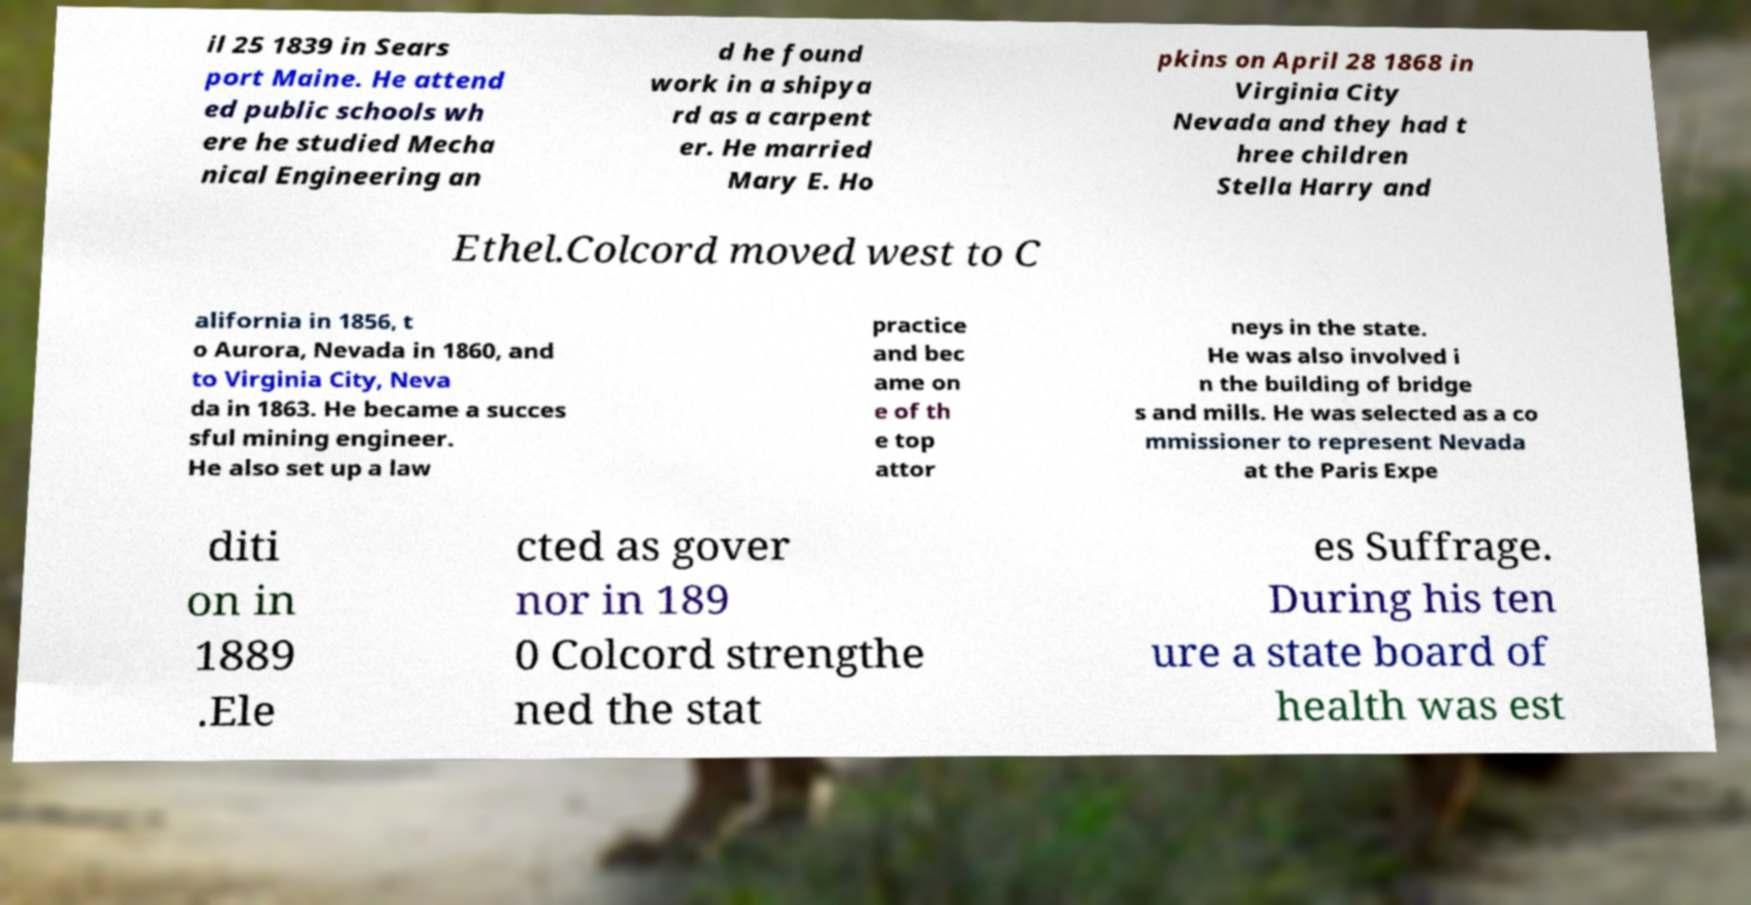Please read and relay the text visible in this image. What does it say? il 25 1839 in Sears port Maine. He attend ed public schools wh ere he studied Mecha nical Engineering an d he found work in a shipya rd as a carpent er. He married Mary E. Ho pkins on April 28 1868 in Virginia City Nevada and they had t hree children Stella Harry and Ethel.Colcord moved west to C alifornia in 1856, t o Aurora, Nevada in 1860, and to Virginia City, Neva da in 1863. He became a succes sful mining engineer. He also set up a law practice and bec ame on e of th e top attor neys in the state. He was also involved i n the building of bridge s and mills. He was selected as a co mmissioner to represent Nevada at the Paris Expe diti on in 1889 .Ele cted as gover nor in 189 0 Colcord strengthe ned the stat es Suffrage. During his ten ure a state board of health was est 